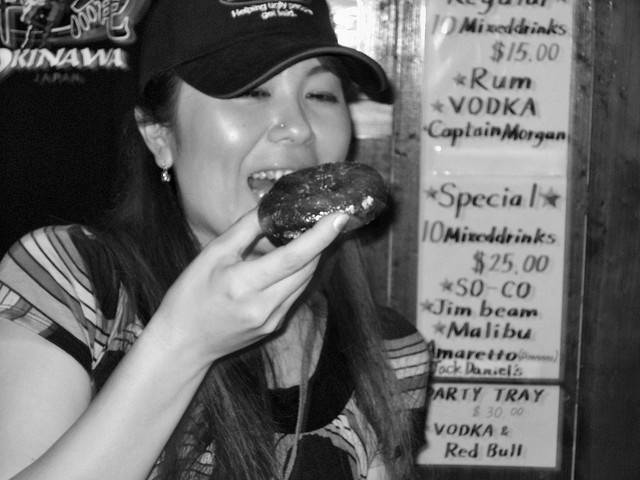Describe the objects in this image and their specific colors. I can see people in gray, black, darkgray, and lightgray tones and donut in gray, black, darkgray, and lightgray tones in this image. 